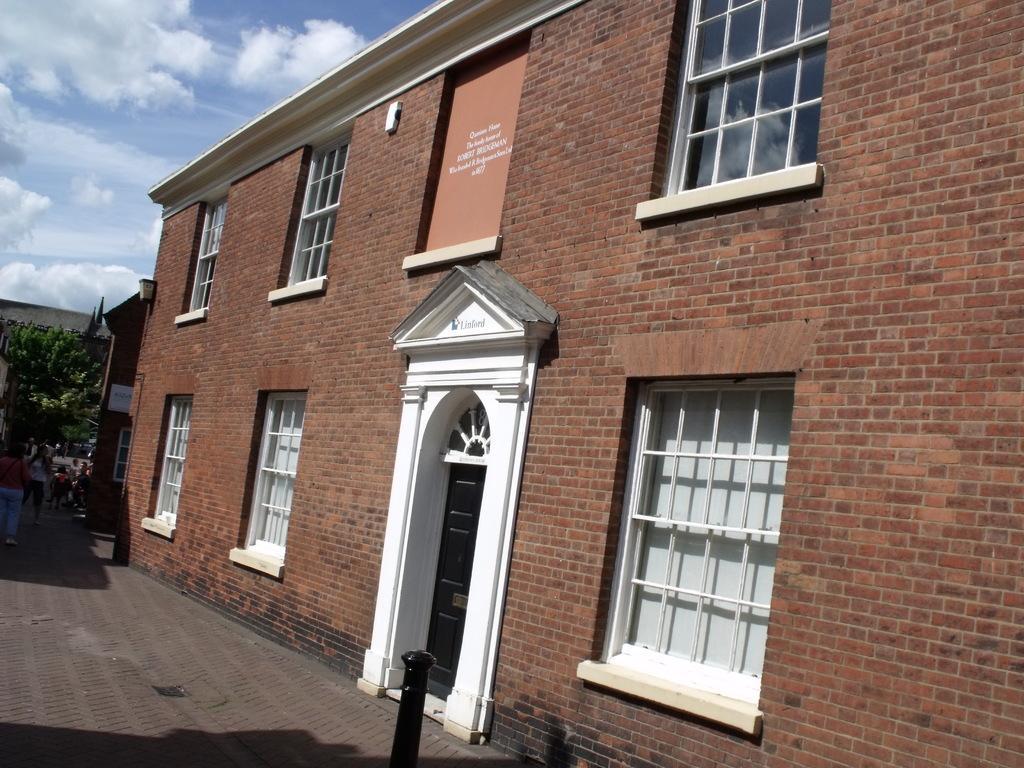Could you give a brief overview of what you see in this image? In the image there is a brick building with doors and windows on the right side, on the left there are few people walking and in the back there are trees and above its sky. 